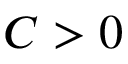<formula> <loc_0><loc_0><loc_500><loc_500>C > 0</formula> 